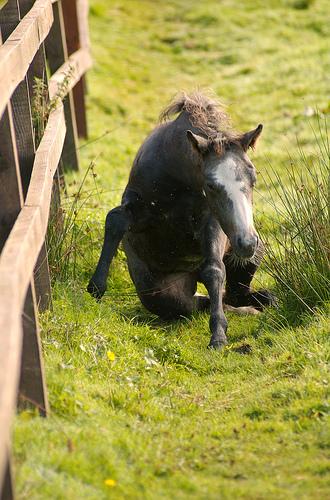Is this a wild horse?
Keep it brief. No. What is the animal near?
Be succinct. Fence. What animal is that?
Quick response, please. Horse. Is the animal sitting or standing?
Give a very brief answer. Sitting. 